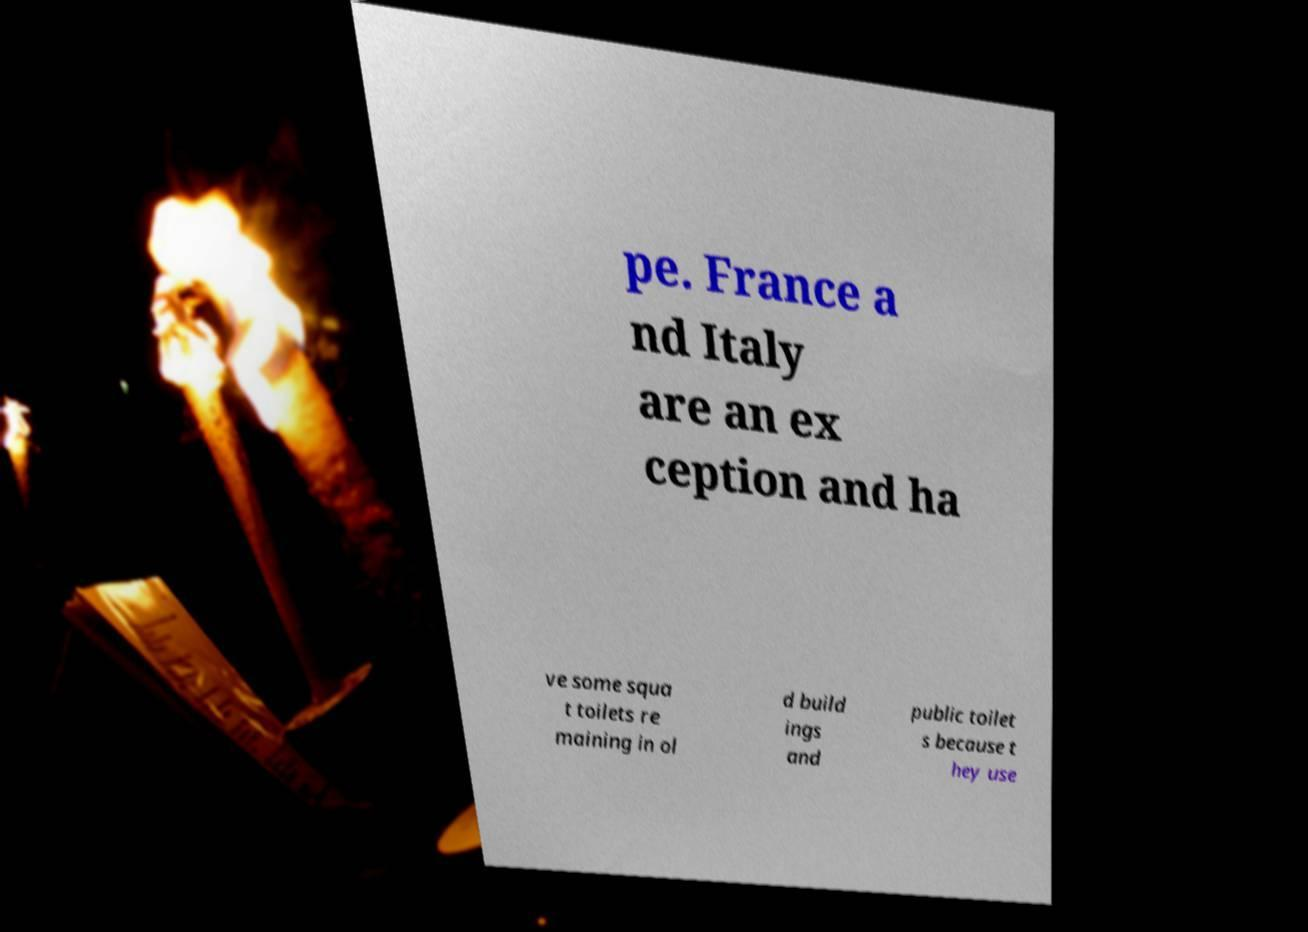I need the written content from this picture converted into text. Can you do that? pe. France a nd Italy are an ex ception and ha ve some squa t toilets re maining in ol d build ings and public toilet s because t hey use 